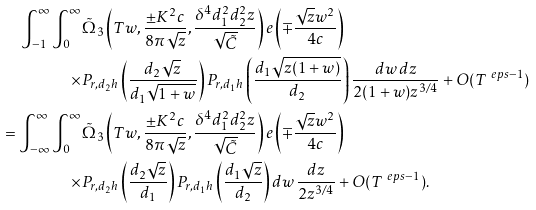Convert formula to latex. <formula><loc_0><loc_0><loc_500><loc_500>\int _ { - 1 } ^ { \infty } \int _ { 0 } ^ { \infty } & \tilde { \Omega } _ { 3 } \left ( T w , \frac { \pm K ^ { 2 } c } { 8 \pi \sqrt { z } } , \frac { \delta ^ { 4 } d _ { 1 } ^ { 2 } d _ { 2 } ^ { 2 } z } { \sqrt { \tilde { C } } } \right ) e \left ( \mp \frac { \sqrt { z } w ^ { 2 } } { 4 c } \right ) \\ \times & P _ { r , d _ { 2 } h } \left ( \frac { d _ { 2 } \sqrt { z } } { d _ { 1 } \sqrt { 1 + w } } \right ) P _ { r , d _ { 1 } h } \left ( \frac { d _ { 1 } \sqrt { z ( 1 + w ) } } { d _ { 2 } } \right ) \frac { d w \, d z } { 2 ( 1 + w ) z ^ { 3 / 4 } } + O ( T ^ { \ e p s - 1 } ) \\ = \int _ { - \infty } ^ { \infty } \int _ { 0 } ^ { \infty } & \tilde { \Omega } _ { 3 } \left ( T w , \frac { \pm K ^ { 2 } c } { 8 \pi \sqrt { z } } , \frac { \delta ^ { 4 } d _ { 1 } ^ { 2 } d _ { 2 } ^ { 2 } z } { \sqrt { \tilde { C } } } \right ) e \left ( \mp \frac { \sqrt { z } w ^ { 2 } } { 4 c } \right ) \\ \times & P _ { r , d _ { 2 } h } \left ( \frac { d _ { 2 } \sqrt { z } } { d _ { 1 } } \right ) P _ { r , d _ { 1 } h } \left ( \frac { d _ { 1 } \sqrt { z } } { d _ { 2 } } \right ) d w \, \frac { d z } { 2 z ^ { 3 / 4 } } + O ( T ^ { \ e p s - 1 } ) .</formula> 